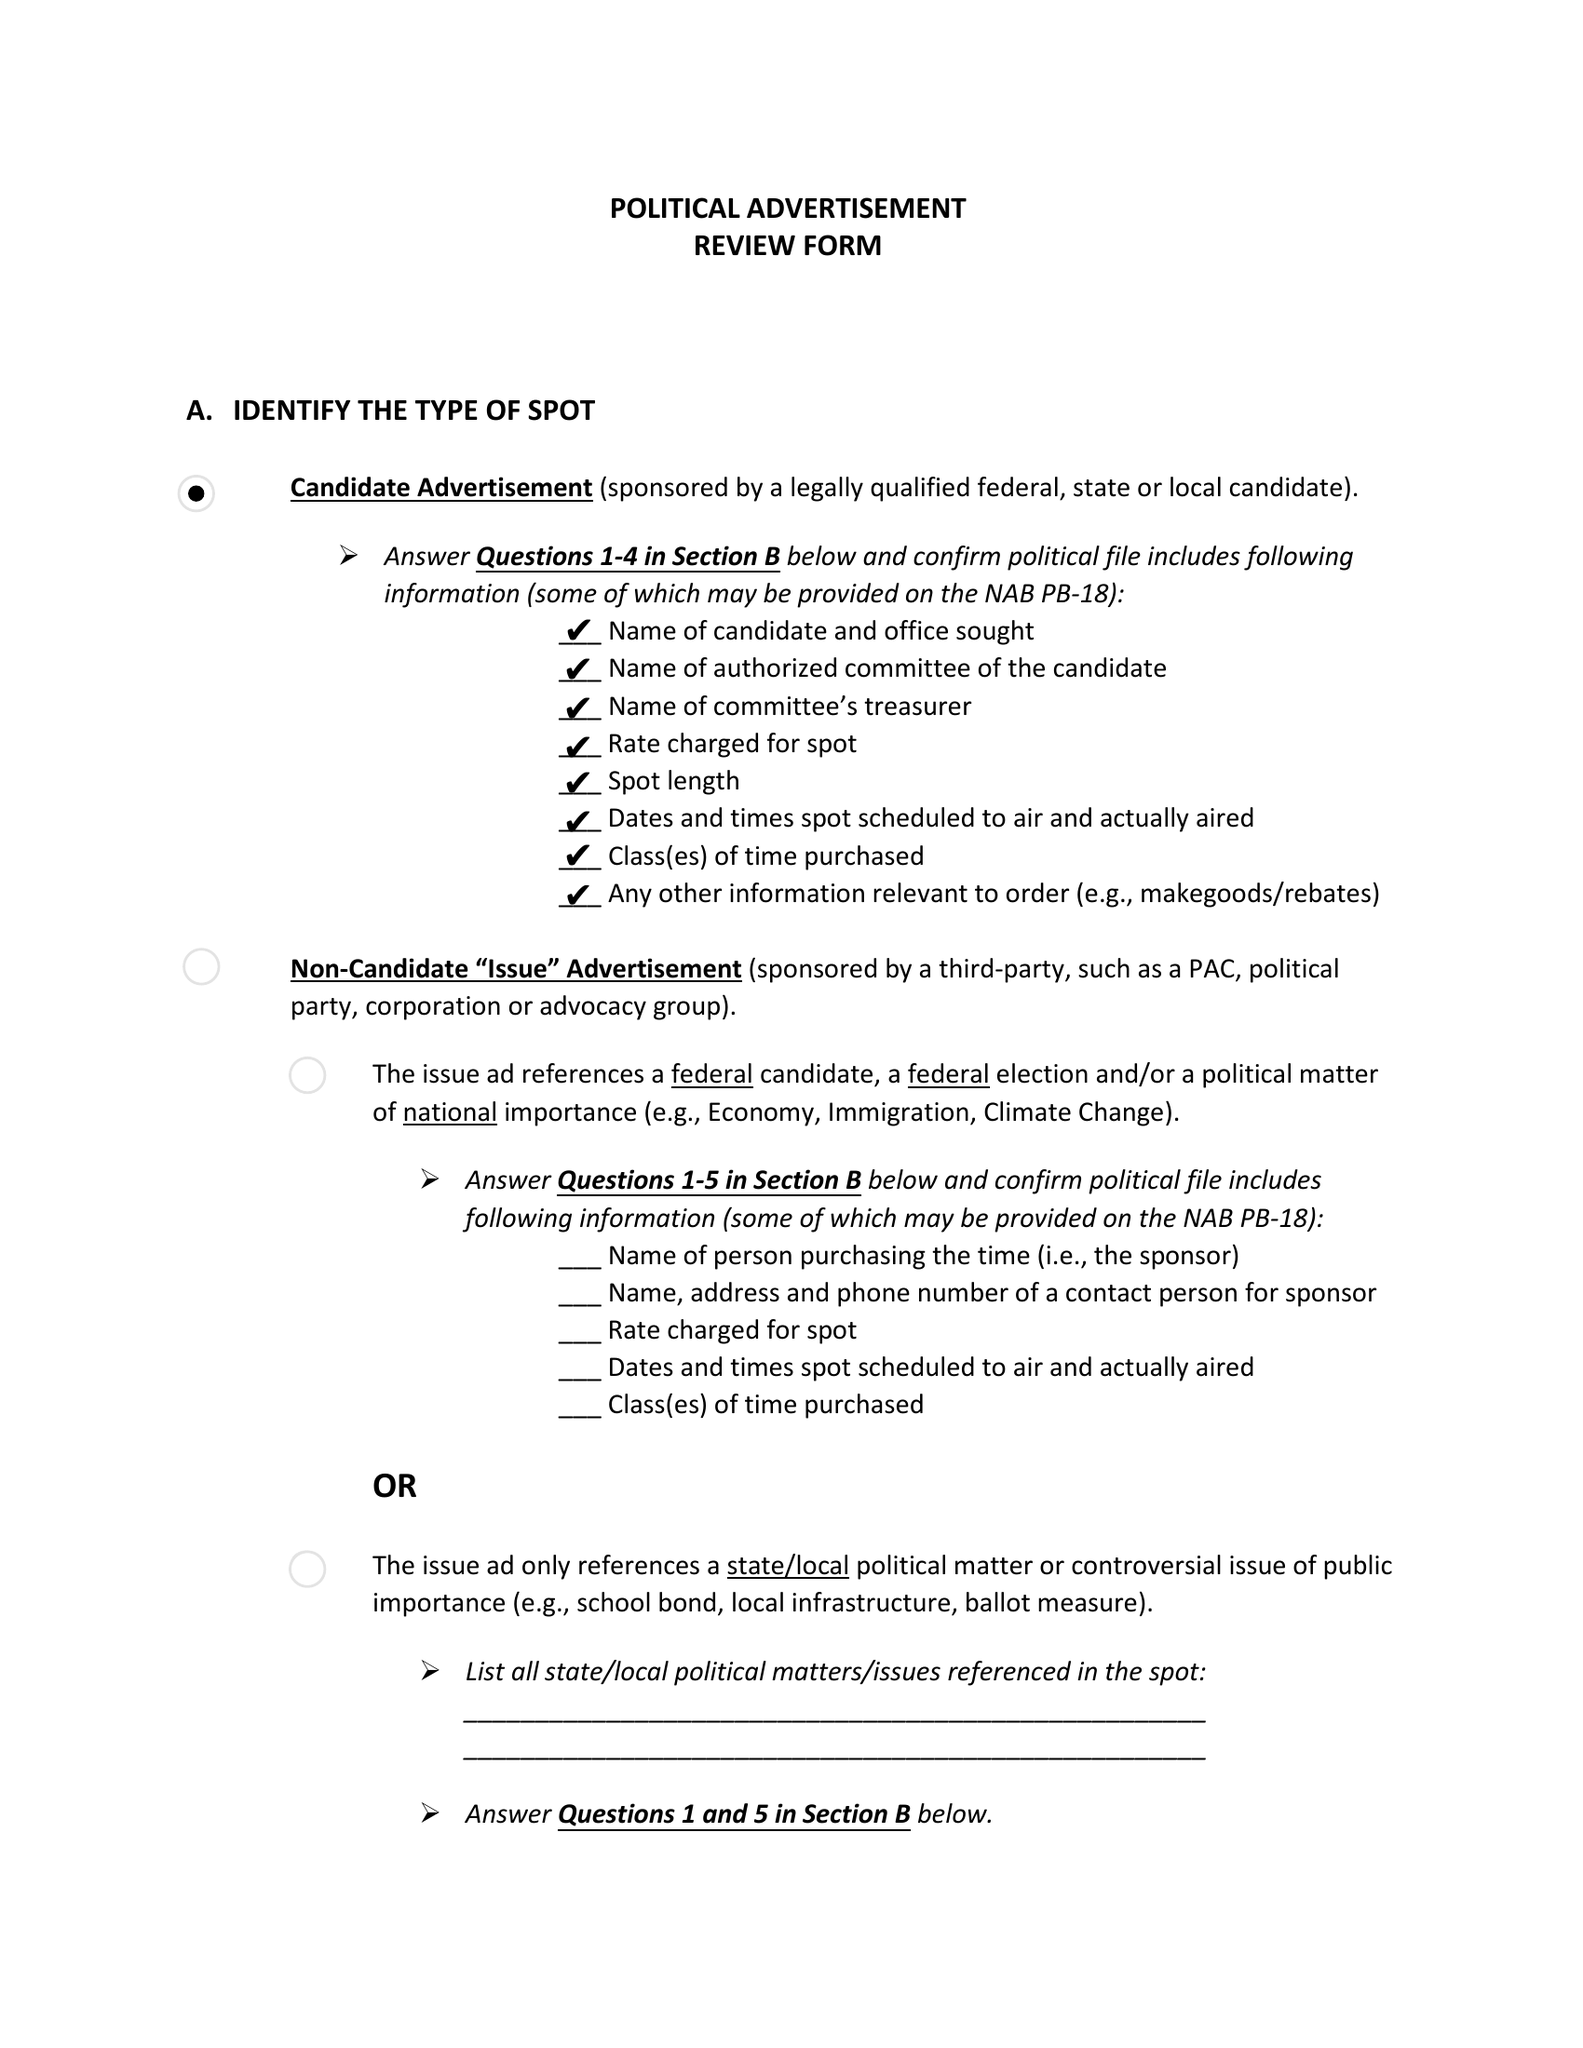What is the value for the advertiser?
Answer the question using a single word or phrase. MIKE BLOOMBERG 